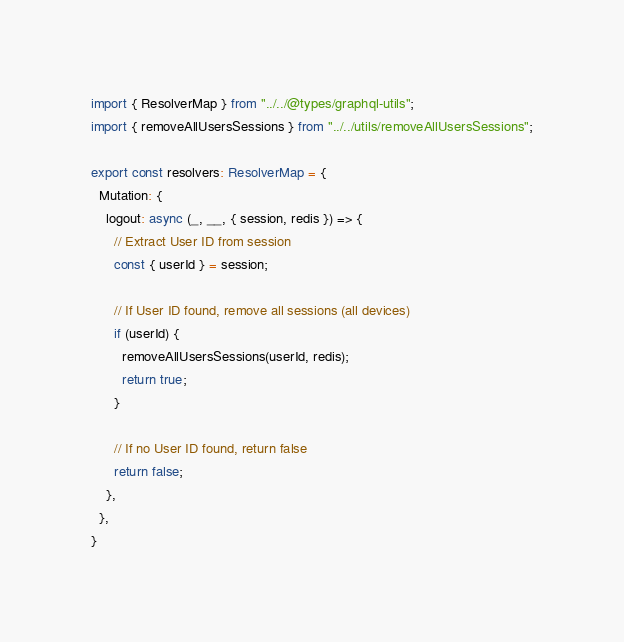Convert code to text. <code><loc_0><loc_0><loc_500><loc_500><_TypeScript_>import { ResolverMap } from "../../@types/graphql-utils";
import { removeAllUsersSessions } from "../../utils/removeAllUsersSessions";

export const resolvers: ResolverMap = {
  Mutation: {
    logout: async (_, __, { session, redis }) => {
      // Extract User ID from session
      const { userId } = session;

      // If User ID found, remove all sessions (all devices)
      if (userId) {
        removeAllUsersSessions(userId, redis);
        return true;
      }

      // If no User ID found, return false
      return false;
    },
  },
}</code> 